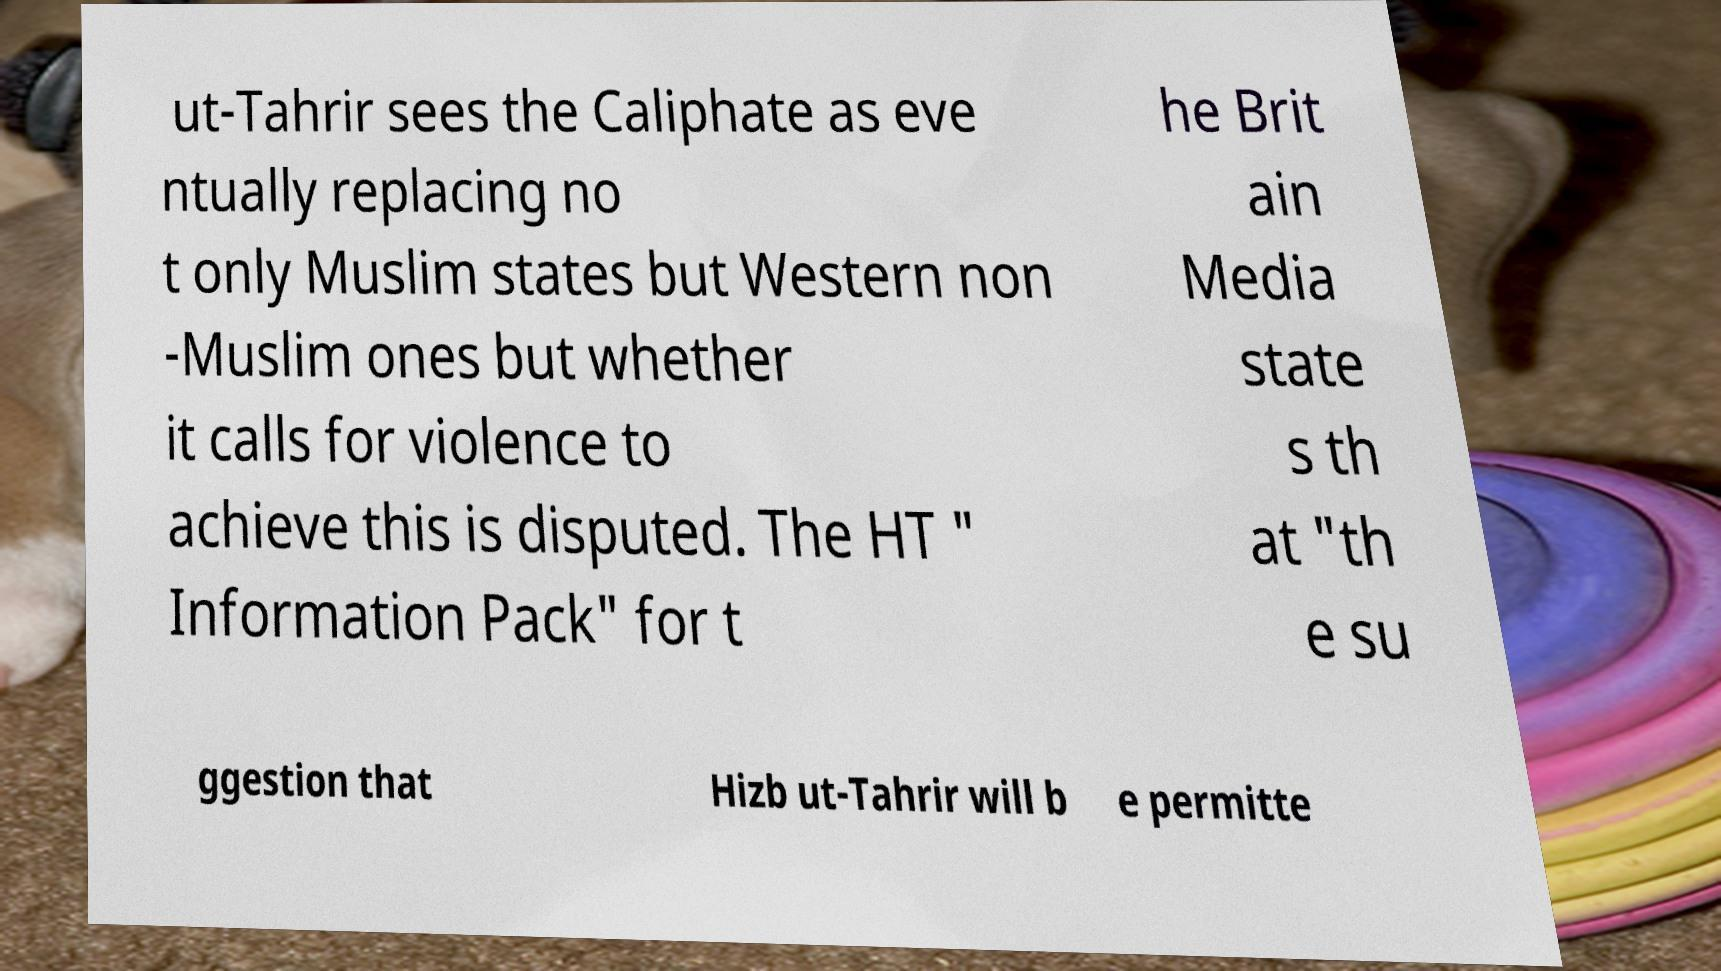Can you accurately transcribe the text from the provided image for me? ut-Tahrir sees the Caliphate as eve ntually replacing no t only Muslim states but Western non -Muslim ones but whether it calls for violence to achieve this is disputed. The HT " Information Pack" for t he Brit ain Media state s th at "th e su ggestion that Hizb ut-Tahrir will b e permitte 